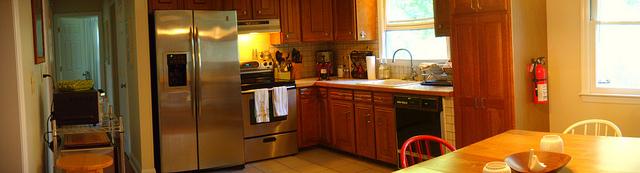Is there a mirror in the photo?
Short answer required. No. Do both of the chairs at the table match?
Quick response, please. No. Does the refrigerator have an ice maker?
Quick response, please. Yes. What color is the oven?
Be succinct. Silver. What room is this?
Concise answer only. Kitchen. How many red chairs are there?
Keep it brief. 1. 